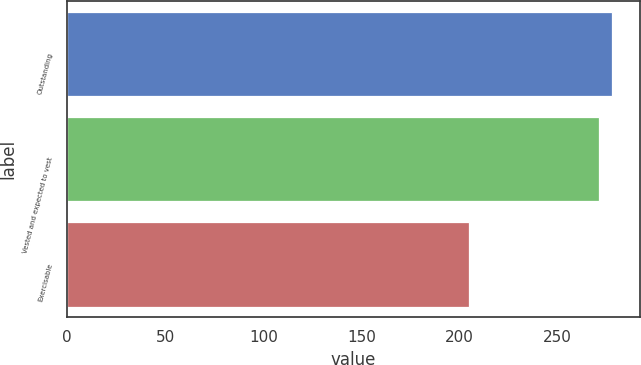Convert chart to OTSL. <chart><loc_0><loc_0><loc_500><loc_500><bar_chart><fcel>Outstanding<fcel>Vested and expected to vest<fcel>Exercisable<nl><fcel>277.8<fcel>271<fcel>205<nl></chart> 